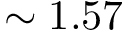<formula> <loc_0><loc_0><loc_500><loc_500>\sim 1 . 5 7</formula> 